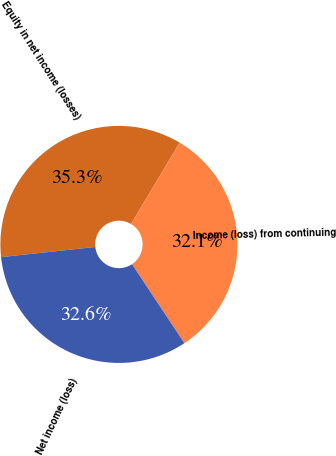Convert chart. <chart><loc_0><loc_0><loc_500><loc_500><pie_chart><fcel>Equity in net income (losses)<fcel>Income (loss) from continuing<fcel>Net income (loss)<nl><fcel>35.28%<fcel>32.11%<fcel>32.61%<nl></chart> 